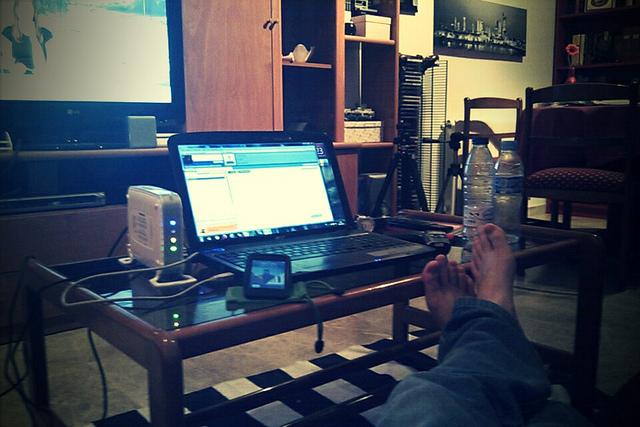What type of footwear is the person wearing?
Write a very short answer. None. IS the laptop on?
Answer briefly. Yes. How many bottles of water are on the table?
Keep it brief. 2. 